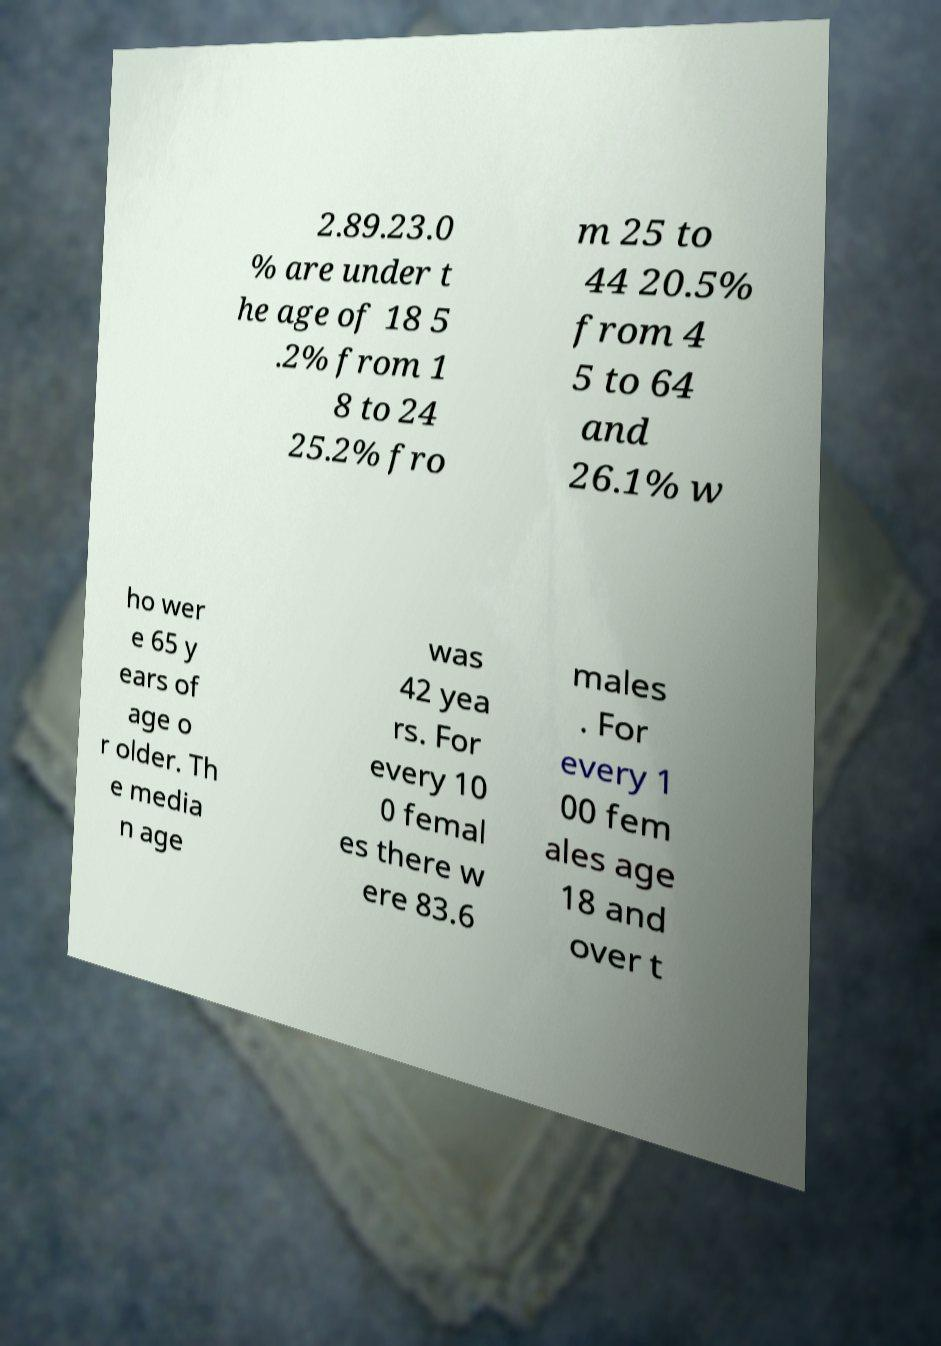For documentation purposes, I need the text within this image transcribed. Could you provide that? 2.89.23.0 % are under t he age of 18 5 .2% from 1 8 to 24 25.2% fro m 25 to 44 20.5% from 4 5 to 64 and 26.1% w ho wer e 65 y ears of age o r older. Th e media n age was 42 yea rs. For every 10 0 femal es there w ere 83.6 males . For every 1 00 fem ales age 18 and over t 